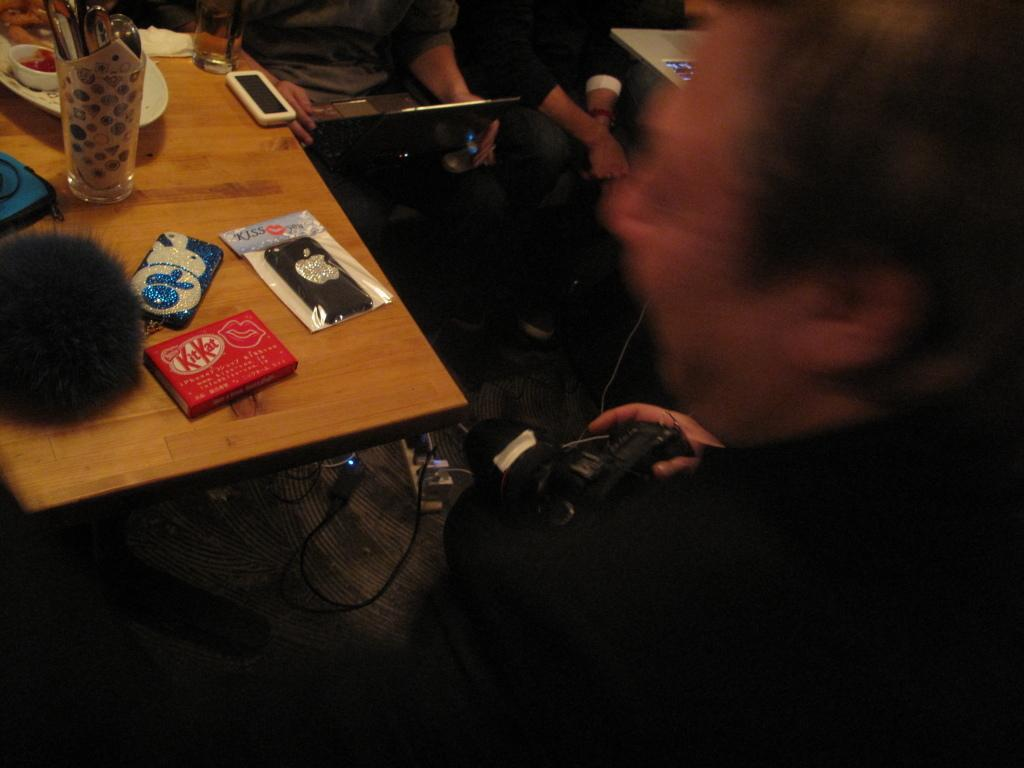What are the people in the image doing? The people in the image are seated. What is the man in the image doing? The man in the image is standing and holding a camera in his hand. What items related to mobile phones can be seen in the image? There are mobile pouches and mobile phones in the image. What can be found on the table in the image? There are plates and a glass on the table. What type of plane is visible on the roof in the image? There is no plane or roof present in the image. What is inside the box on the table in the image? There is no box present on the table in the image. 